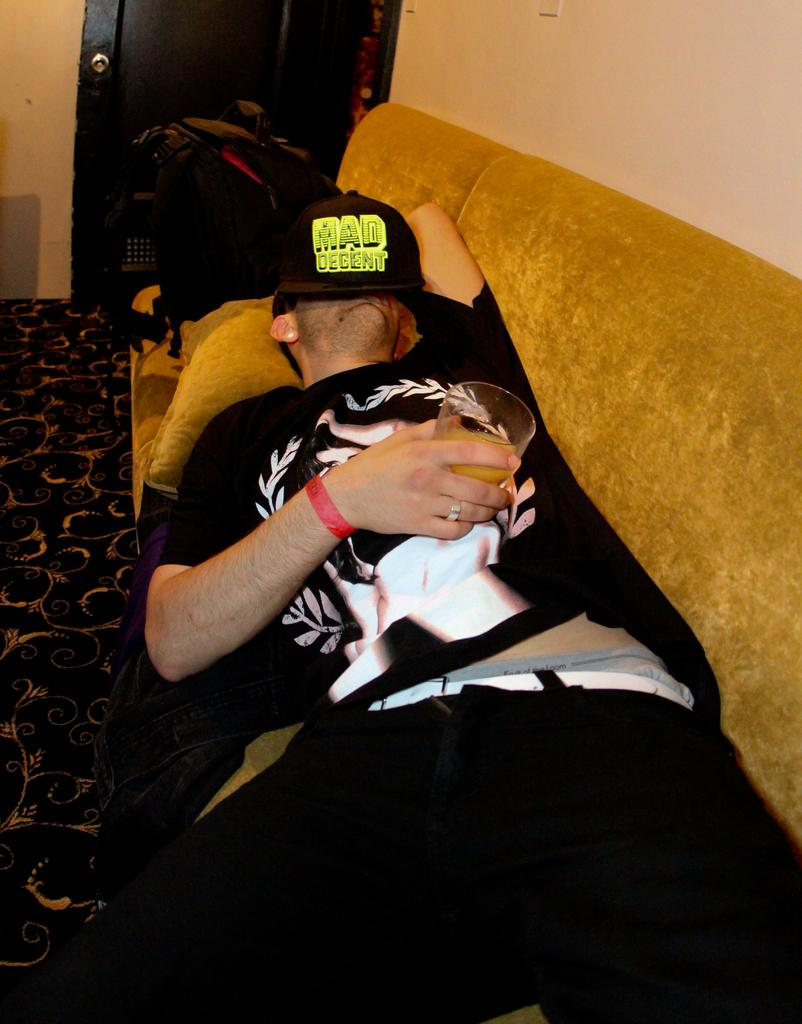What is the person in the image doing? The person is laying on a sofa. What is the person holding in the image? The person is holding a glass. What is covering the person's face? There is a cap on the person's face. What can be seen in the background of the image? There is a wall, a door, and a bag visible in the background of the image. What type of surface is the person laying on? The person is laying on a sofa, which is a type of furniture. What type of celery is the person eating in the image? There is no celery present in the image; the person is holding a glass. How many dimes can be seen on the person's forehead in the image? There are no dimes visible in the image; the person is wearing a cap on their face. 